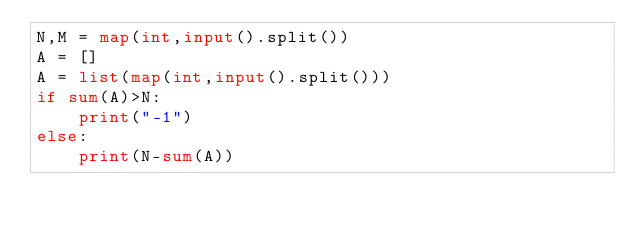<code> <loc_0><loc_0><loc_500><loc_500><_Python_>N,M = map(int,input().split())
A = []
A = list(map(int,input().split()))
if sum(A)>N:
    print("-1")
else:
    print(N-sum(A))</code> 